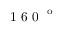<formula> <loc_0><loc_0><loc_500><loc_500>1 6 0 ^ { o }</formula> 